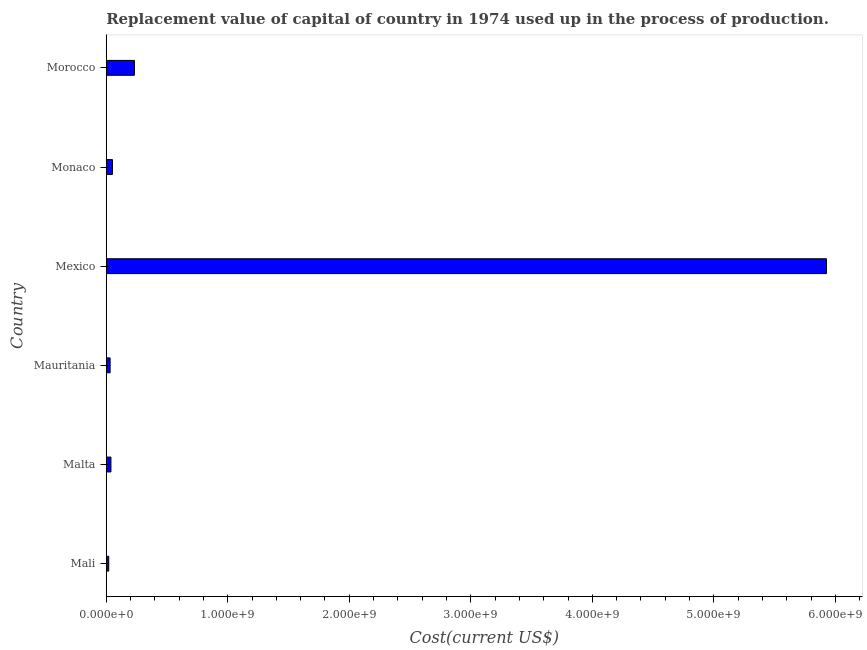What is the title of the graph?
Make the answer very short. Replacement value of capital of country in 1974 used up in the process of production. What is the label or title of the X-axis?
Give a very brief answer. Cost(current US$). What is the consumption of fixed capital in Malta?
Your answer should be very brief. 3.86e+07. Across all countries, what is the maximum consumption of fixed capital?
Ensure brevity in your answer.  5.93e+09. Across all countries, what is the minimum consumption of fixed capital?
Your answer should be compact. 2.05e+07. In which country was the consumption of fixed capital minimum?
Provide a short and direct response. Mali. What is the sum of the consumption of fixed capital?
Provide a succinct answer. 6.30e+09. What is the difference between the consumption of fixed capital in Mauritania and Monaco?
Offer a very short reply. -1.93e+07. What is the average consumption of fixed capital per country?
Offer a terse response. 1.05e+09. What is the median consumption of fixed capital?
Give a very brief answer. 4.49e+07. What is the ratio of the consumption of fixed capital in Monaco to that in Morocco?
Give a very brief answer. 0.22. What is the difference between the highest and the second highest consumption of fixed capital?
Your response must be concise. 5.69e+09. What is the difference between the highest and the lowest consumption of fixed capital?
Give a very brief answer. 5.91e+09. How many bars are there?
Your answer should be very brief. 6. What is the difference between two consecutive major ticks on the X-axis?
Keep it short and to the point. 1.00e+09. What is the Cost(current US$) of Mali?
Provide a short and direct response. 2.05e+07. What is the Cost(current US$) in Malta?
Ensure brevity in your answer.  3.86e+07. What is the Cost(current US$) in Mauritania?
Your answer should be compact. 3.18e+07. What is the Cost(current US$) in Mexico?
Give a very brief answer. 5.93e+09. What is the Cost(current US$) of Monaco?
Make the answer very short. 5.11e+07. What is the Cost(current US$) of Morocco?
Your response must be concise. 2.32e+08. What is the difference between the Cost(current US$) in Mali and Malta?
Ensure brevity in your answer.  -1.81e+07. What is the difference between the Cost(current US$) in Mali and Mauritania?
Offer a terse response. -1.14e+07. What is the difference between the Cost(current US$) in Mali and Mexico?
Provide a short and direct response. -5.91e+09. What is the difference between the Cost(current US$) in Mali and Monaco?
Your answer should be very brief. -3.06e+07. What is the difference between the Cost(current US$) in Mali and Morocco?
Ensure brevity in your answer.  -2.11e+08. What is the difference between the Cost(current US$) in Malta and Mauritania?
Keep it short and to the point. 6.78e+06. What is the difference between the Cost(current US$) in Malta and Mexico?
Your answer should be compact. -5.89e+09. What is the difference between the Cost(current US$) in Malta and Monaco?
Offer a very short reply. -1.25e+07. What is the difference between the Cost(current US$) in Malta and Morocco?
Provide a short and direct response. -1.93e+08. What is the difference between the Cost(current US$) in Mauritania and Mexico?
Keep it short and to the point. -5.89e+09. What is the difference between the Cost(current US$) in Mauritania and Monaco?
Your answer should be very brief. -1.93e+07. What is the difference between the Cost(current US$) in Mauritania and Morocco?
Give a very brief answer. -2.00e+08. What is the difference between the Cost(current US$) in Mexico and Monaco?
Your response must be concise. 5.88e+09. What is the difference between the Cost(current US$) in Mexico and Morocco?
Your answer should be compact. 5.69e+09. What is the difference between the Cost(current US$) in Monaco and Morocco?
Provide a short and direct response. -1.81e+08. What is the ratio of the Cost(current US$) in Mali to that in Malta?
Your answer should be compact. 0.53. What is the ratio of the Cost(current US$) in Mali to that in Mauritania?
Provide a short and direct response. 0.64. What is the ratio of the Cost(current US$) in Mali to that in Mexico?
Provide a succinct answer. 0. What is the ratio of the Cost(current US$) in Mali to that in Monaco?
Offer a terse response. 0.4. What is the ratio of the Cost(current US$) in Mali to that in Morocco?
Offer a terse response. 0.09. What is the ratio of the Cost(current US$) in Malta to that in Mauritania?
Your answer should be compact. 1.21. What is the ratio of the Cost(current US$) in Malta to that in Mexico?
Provide a short and direct response. 0.01. What is the ratio of the Cost(current US$) in Malta to that in Monaco?
Provide a succinct answer. 0.76. What is the ratio of the Cost(current US$) in Malta to that in Morocco?
Provide a short and direct response. 0.17. What is the ratio of the Cost(current US$) in Mauritania to that in Mexico?
Offer a terse response. 0.01. What is the ratio of the Cost(current US$) in Mauritania to that in Monaco?
Your answer should be compact. 0.62. What is the ratio of the Cost(current US$) in Mauritania to that in Morocco?
Provide a succinct answer. 0.14. What is the ratio of the Cost(current US$) in Mexico to that in Monaco?
Ensure brevity in your answer.  116. What is the ratio of the Cost(current US$) in Mexico to that in Morocco?
Keep it short and to the point. 25.57. What is the ratio of the Cost(current US$) in Monaco to that in Morocco?
Offer a terse response. 0.22. 